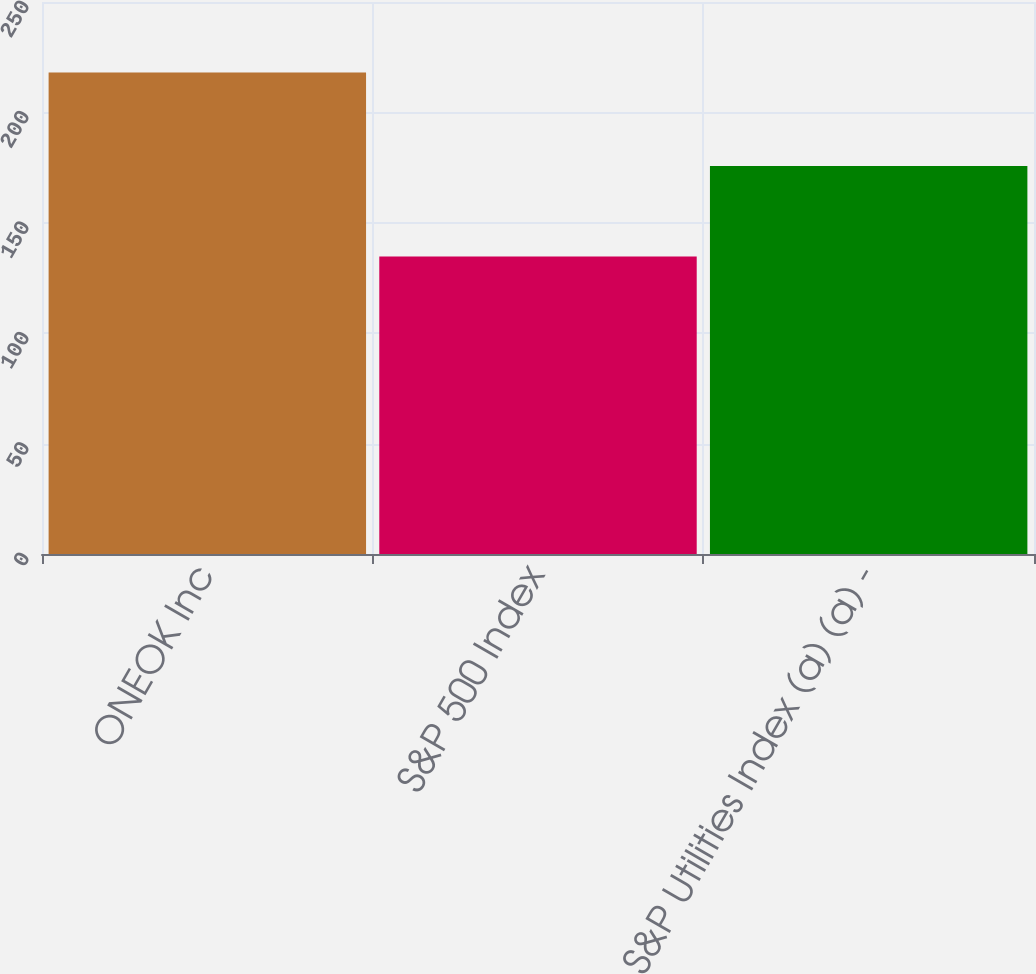<chart> <loc_0><loc_0><loc_500><loc_500><bar_chart><fcel>ONEOK Inc<fcel>S&P 500 Index<fcel>S&P Utilities Index (a) (a) -<nl><fcel>218.1<fcel>134.69<fcel>175.69<nl></chart> 